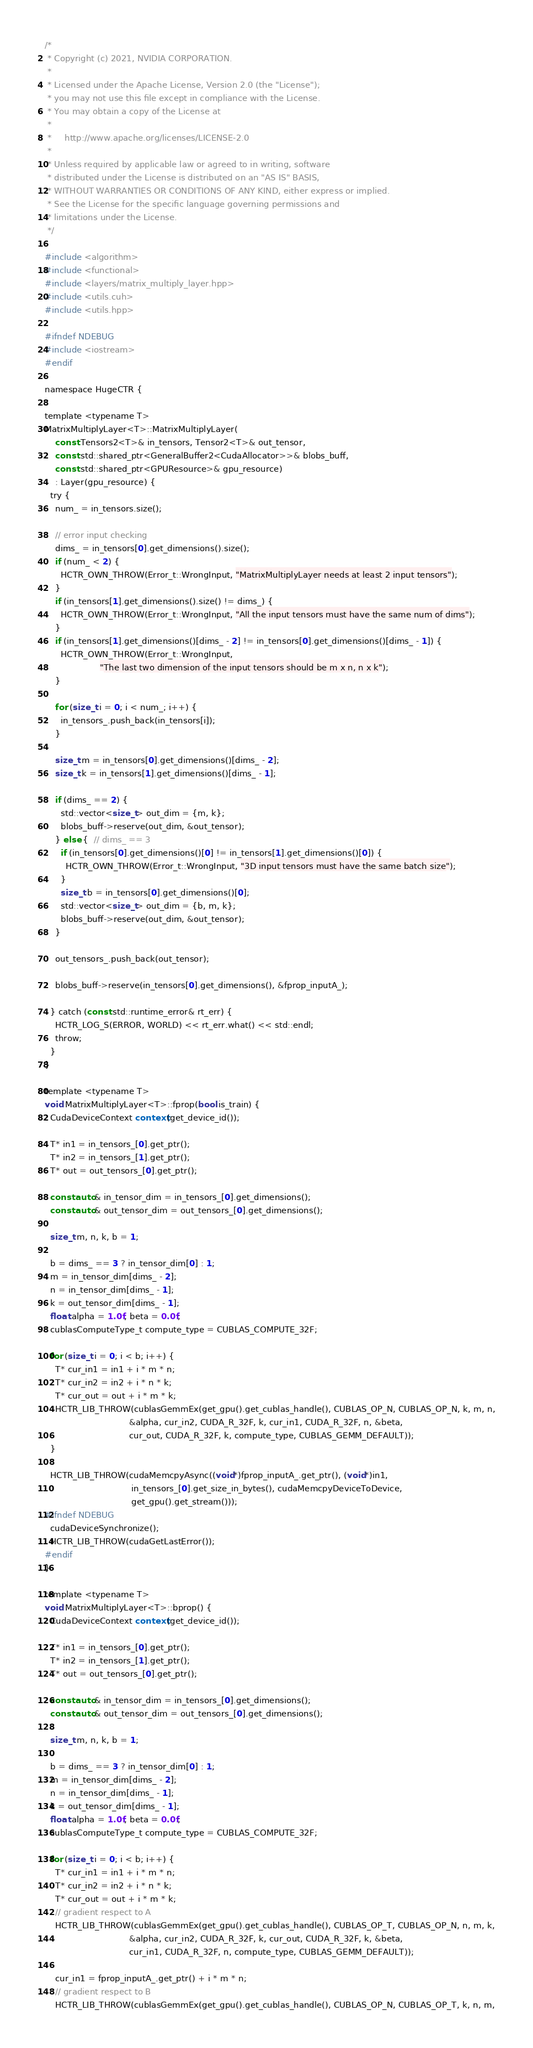Convert code to text. <code><loc_0><loc_0><loc_500><loc_500><_Cuda_>/*
 * Copyright (c) 2021, NVIDIA CORPORATION.
 *
 * Licensed under the Apache License, Version 2.0 (the "License");
 * you may not use this file except in compliance with the License.
 * You may obtain a copy of the License at
 *
 *     http://www.apache.org/licenses/LICENSE-2.0
 *
 * Unless required by applicable law or agreed to in writing, software
 * distributed under the License is distributed on an "AS IS" BASIS,
 * WITHOUT WARRANTIES OR CONDITIONS OF ANY KIND, either express or implied.
 * See the License for the specific language governing permissions and
 * limitations under the License.
 */

#include <algorithm>
#include <functional>
#include <layers/matrix_multiply_layer.hpp>
#include <utils.cuh>
#include <utils.hpp>

#ifndef NDEBUG
#include <iostream>
#endif

namespace HugeCTR {

template <typename T>
MatrixMultiplyLayer<T>::MatrixMultiplyLayer(
    const Tensors2<T>& in_tensors, Tensor2<T>& out_tensor,
    const std::shared_ptr<GeneralBuffer2<CudaAllocator>>& blobs_buff,
    const std::shared_ptr<GPUResource>& gpu_resource)
    : Layer(gpu_resource) {
  try {
    num_ = in_tensors.size();

    // error input checking
    dims_ = in_tensors[0].get_dimensions().size();
    if (num_ < 2) {
      HCTR_OWN_THROW(Error_t::WrongInput, "MatrixMultiplyLayer needs at least 2 input tensors");
    }
    if (in_tensors[1].get_dimensions().size() != dims_) {
      HCTR_OWN_THROW(Error_t::WrongInput, "All the input tensors must have the same num of dims");
    }
    if (in_tensors[1].get_dimensions()[dims_ - 2] != in_tensors[0].get_dimensions()[dims_ - 1]) {
      HCTR_OWN_THROW(Error_t::WrongInput,
                     "The last two dimension of the input tensors should be m x n, n x k");
    }

    for (size_t i = 0; i < num_; i++) {
      in_tensors_.push_back(in_tensors[i]);
    }

    size_t m = in_tensors[0].get_dimensions()[dims_ - 2];
    size_t k = in_tensors[1].get_dimensions()[dims_ - 1];

    if (dims_ == 2) {
      std::vector<size_t> out_dim = {m, k};
      blobs_buff->reserve(out_dim, &out_tensor);
    } else {  // dims_ == 3
      if (in_tensors[0].get_dimensions()[0] != in_tensors[1].get_dimensions()[0]) {
        HCTR_OWN_THROW(Error_t::WrongInput, "3D input tensors must have the same batch size");
      }
      size_t b = in_tensors[0].get_dimensions()[0];
      std::vector<size_t> out_dim = {b, m, k};
      blobs_buff->reserve(out_dim, &out_tensor);
    }

    out_tensors_.push_back(out_tensor);

    blobs_buff->reserve(in_tensors[0].get_dimensions(), &fprop_inputA_);

  } catch (const std::runtime_error& rt_err) {
    HCTR_LOG_S(ERROR, WORLD) << rt_err.what() << std::endl;
    throw;
  }
}

template <typename T>
void MatrixMultiplyLayer<T>::fprop(bool is_train) {
  CudaDeviceContext context(get_device_id());

  T* in1 = in_tensors_[0].get_ptr();
  T* in2 = in_tensors_[1].get_ptr();
  T* out = out_tensors_[0].get_ptr();

  const auto& in_tensor_dim = in_tensors_[0].get_dimensions();
  const auto& out_tensor_dim = out_tensors_[0].get_dimensions();

  size_t m, n, k, b = 1;

  b = dims_ == 3 ? in_tensor_dim[0] : 1;
  m = in_tensor_dim[dims_ - 2];
  n = in_tensor_dim[dims_ - 1];
  k = out_tensor_dim[dims_ - 1];
  float alpha = 1.0f, beta = 0.0f;
  cublasComputeType_t compute_type = CUBLAS_COMPUTE_32F;

  for (size_t i = 0; i < b; i++) {
    T* cur_in1 = in1 + i * m * n;
    T* cur_in2 = in2 + i * n * k;
    T* cur_out = out + i * m * k;
    HCTR_LIB_THROW(cublasGemmEx(get_gpu().get_cublas_handle(), CUBLAS_OP_N, CUBLAS_OP_N, k, m, n,
                                &alpha, cur_in2, CUDA_R_32F, k, cur_in1, CUDA_R_32F, n, &beta,
                                cur_out, CUDA_R_32F, k, compute_type, CUBLAS_GEMM_DEFAULT));
  }

  HCTR_LIB_THROW(cudaMemcpyAsync((void*)fprop_inputA_.get_ptr(), (void*)in1,
                                 in_tensors_[0].get_size_in_bytes(), cudaMemcpyDeviceToDevice,
                                 get_gpu().get_stream()));
#ifndef NDEBUG
  cudaDeviceSynchronize();
  HCTR_LIB_THROW(cudaGetLastError());
#endif
}

template <typename T>
void MatrixMultiplyLayer<T>::bprop() {
  CudaDeviceContext context(get_device_id());

  T* in1 = in_tensors_[0].get_ptr();
  T* in2 = in_tensors_[1].get_ptr();
  T* out = out_tensors_[0].get_ptr();

  const auto& in_tensor_dim = in_tensors_[0].get_dimensions();
  const auto& out_tensor_dim = out_tensors_[0].get_dimensions();

  size_t m, n, k, b = 1;

  b = dims_ == 3 ? in_tensor_dim[0] : 1;
  m = in_tensor_dim[dims_ - 2];
  n = in_tensor_dim[dims_ - 1];
  k = out_tensor_dim[dims_ - 1];
  float alpha = 1.0f, beta = 0.0f;
  cublasComputeType_t compute_type = CUBLAS_COMPUTE_32F;

  for (size_t i = 0; i < b; i++) {
    T* cur_in1 = in1 + i * m * n;
    T* cur_in2 = in2 + i * n * k;
    T* cur_out = out + i * m * k;
    // gradient respect to A
    HCTR_LIB_THROW(cublasGemmEx(get_gpu().get_cublas_handle(), CUBLAS_OP_T, CUBLAS_OP_N, n, m, k,
                                &alpha, cur_in2, CUDA_R_32F, k, cur_out, CUDA_R_32F, k, &beta,
                                cur_in1, CUDA_R_32F, n, compute_type, CUBLAS_GEMM_DEFAULT));

    cur_in1 = fprop_inputA_.get_ptr() + i * m * n;
    // gradient respect to B
    HCTR_LIB_THROW(cublasGemmEx(get_gpu().get_cublas_handle(), CUBLAS_OP_N, CUBLAS_OP_T, k, n, m,</code> 